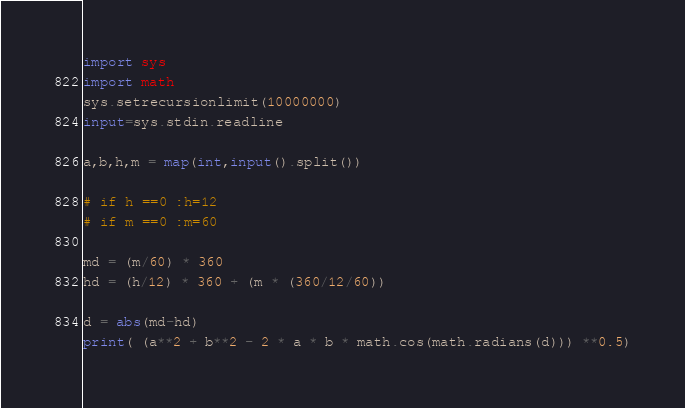Convert code to text. <code><loc_0><loc_0><loc_500><loc_500><_Python_>import sys
import math
sys.setrecursionlimit(10000000)
input=sys.stdin.readline

a,b,h,m = map(int,input().split())

# if h ==0 :h=12  
# if m ==0 :m=60

md = (m/60) * 360
hd = (h/12) * 360 + (m * (360/12/60))

d = abs(md-hd)
print( (a**2 + b**2 - 2 * a * b * math.cos(math.radians(d))) **0.5)
</code> 